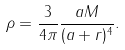<formula> <loc_0><loc_0><loc_500><loc_500>\rho = \frac { 3 } { 4 \pi } \frac { a M } { ( a + r ) ^ { 4 } } .</formula> 